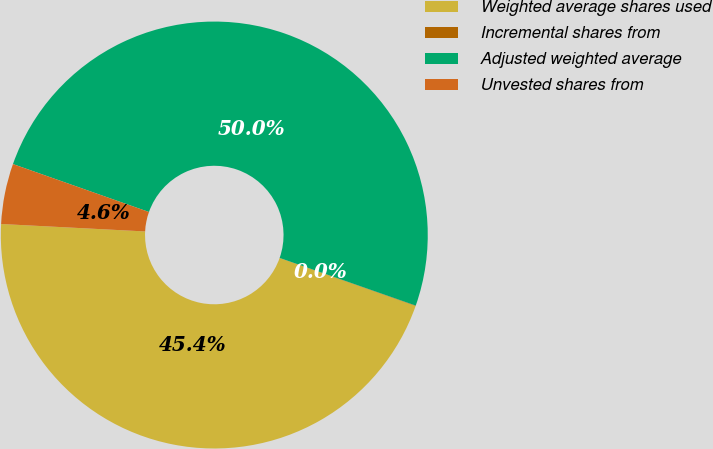Convert chart. <chart><loc_0><loc_0><loc_500><loc_500><pie_chart><fcel>Weighted average shares used<fcel>Incremental shares from<fcel>Adjusted weighted average<fcel>Unvested shares from<nl><fcel>45.43%<fcel>0.03%<fcel>49.97%<fcel>4.57%<nl></chart> 